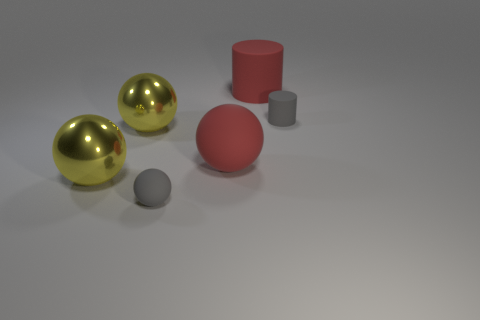Subtract 1 balls. How many balls are left? 3 Subtract all cyan spheres. Subtract all purple cylinders. How many spheres are left? 4 Add 1 tiny matte things. How many objects exist? 7 Subtract all spheres. How many objects are left? 2 Add 3 metal spheres. How many metal spheres are left? 5 Add 3 large purple cylinders. How many large purple cylinders exist? 3 Subtract 0 blue cubes. How many objects are left? 6 Subtract all tiny gray rubber cylinders. Subtract all rubber things. How many objects are left? 1 